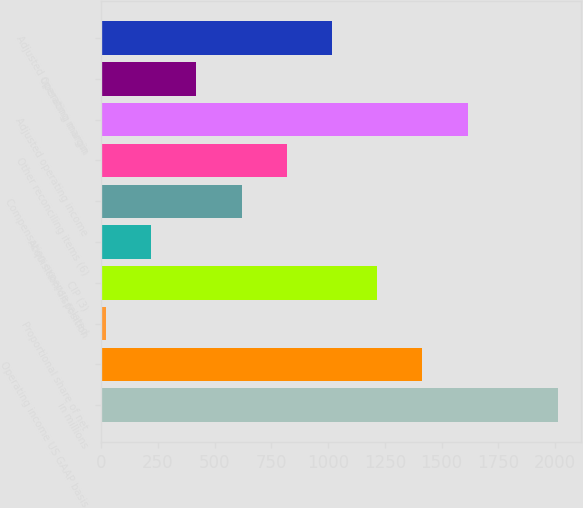<chart> <loc_0><loc_0><loc_500><loc_500><bar_chart><fcel>in millions<fcel>Operating income US GAAP basis<fcel>Proportional share of net<fcel>CIP (3)<fcel>Acquisition/disposition<fcel>Compensation expense related<fcel>Other reconciling items (6)<fcel>Adjusted operating income<fcel>Operating margin<fcel>Adjusted operating margin<nl><fcel>2013<fcel>1415.49<fcel>21.3<fcel>1216.32<fcel>220.47<fcel>618.81<fcel>817.98<fcel>1614.66<fcel>419.64<fcel>1017.15<nl></chart> 